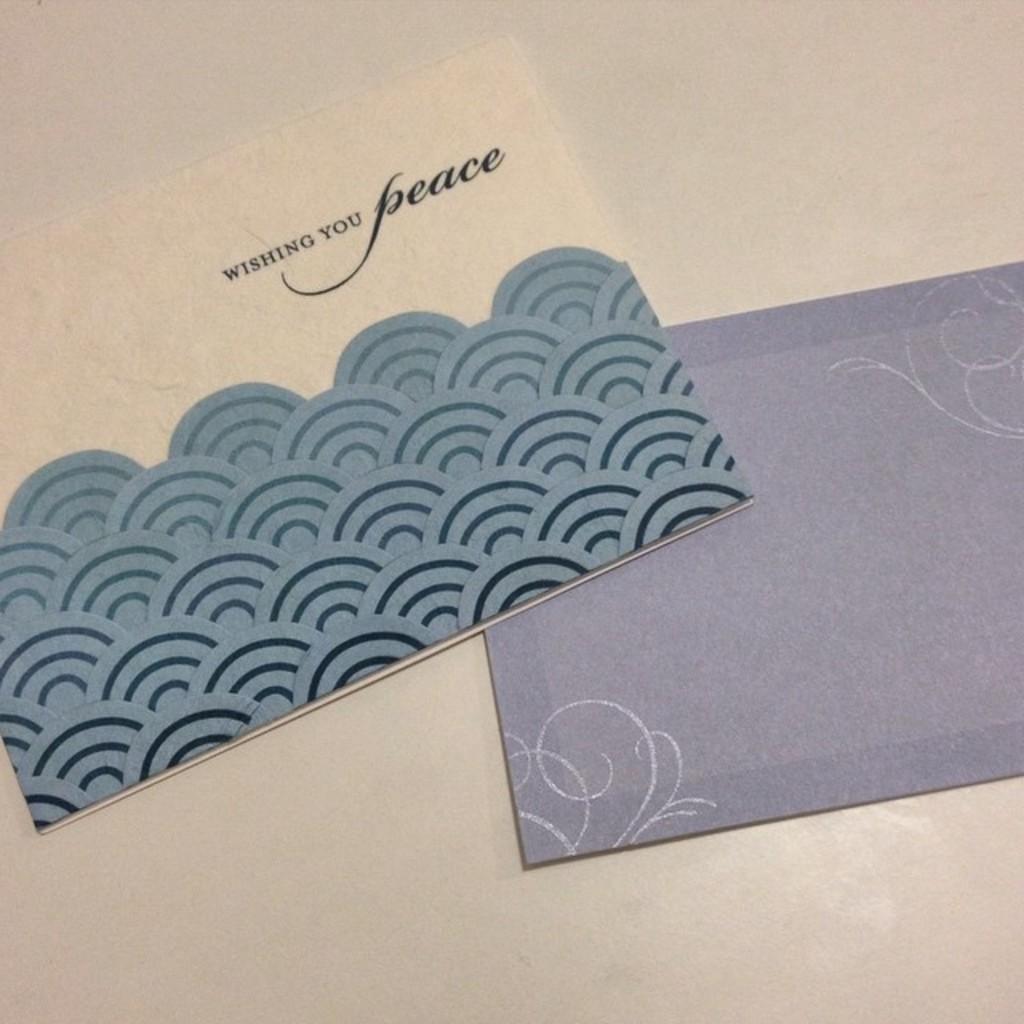What does the card wish?
Offer a very short reply. Peace. What does the card say?
Your answer should be compact. Wishing you peace. 